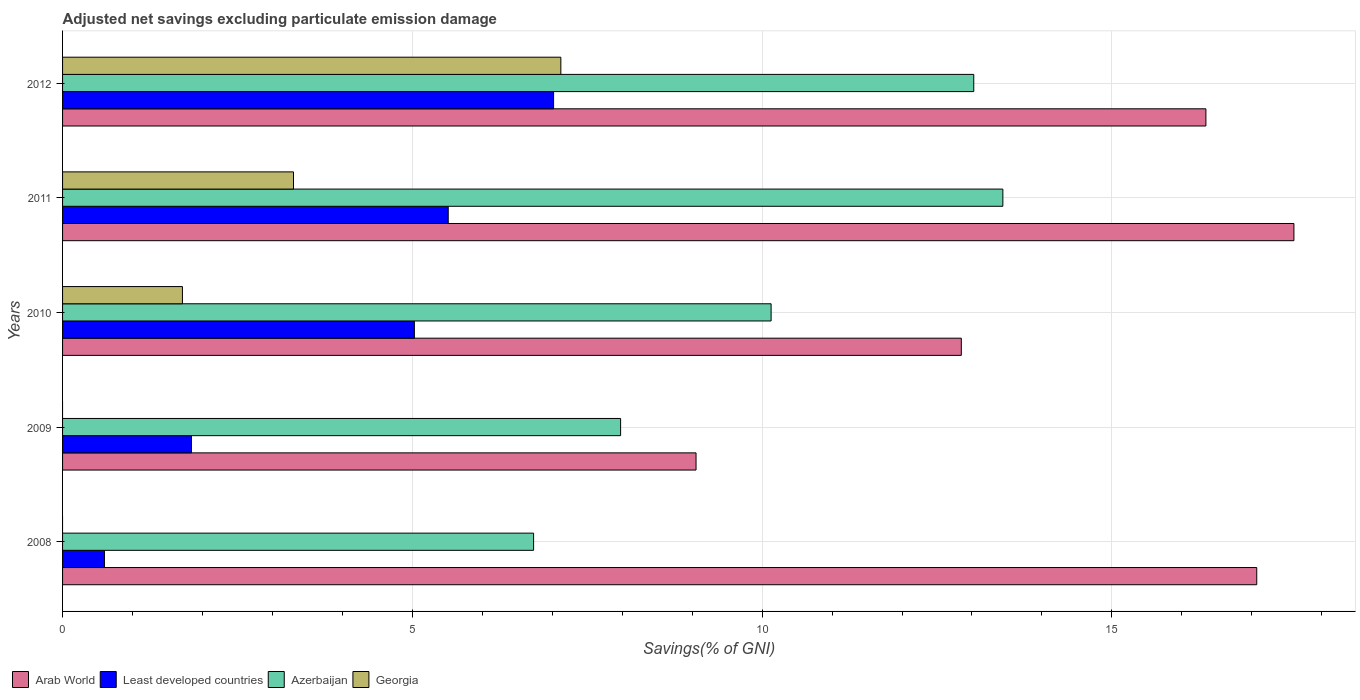How many groups of bars are there?
Provide a succinct answer. 5. How many bars are there on the 5th tick from the top?
Provide a short and direct response. 3. How many bars are there on the 3rd tick from the bottom?
Keep it short and to the point. 4. What is the adjusted net savings in Least developed countries in 2010?
Your answer should be compact. 5.03. Across all years, what is the maximum adjusted net savings in Least developed countries?
Keep it short and to the point. 7.02. Across all years, what is the minimum adjusted net savings in Georgia?
Provide a succinct answer. 0. In which year was the adjusted net savings in Georgia maximum?
Provide a short and direct response. 2012. What is the total adjusted net savings in Azerbaijan in the graph?
Offer a terse response. 51.31. What is the difference between the adjusted net savings in Arab World in 2009 and that in 2012?
Your answer should be compact. -7.29. What is the difference between the adjusted net savings in Georgia in 2010 and the adjusted net savings in Arab World in 2012?
Offer a very short reply. -14.63. What is the average adjusted net savings in Arab World per year?
Give a very brief answer. 14.58. In the year 2011, what is the difference between the adjusted net savings in Georgia and adjusted net savings in Least developed countries?
Provide a succinct answer. -2.21. What is the ratio of the adjusted net savings in Least developed countries in 2008 to that in 2009?
Your response must be concise. 0.32. Is the difference between the adjusted net savings in Georgia in 2010 and 2011 greater than the difference between the adjusted net savings in Least developed countries in 2010 and 2011?
Offer a very short reply. No. What is the difference between the highest and the second highest adjusted net savings in Azerbaijan?
Your answer should be very brief. 0.42. What is the difference between the highest and the lowest adjusted net savings in Arab World?
Your response must be concise. 8.55. Is the sum of the adjusted net savings in Arab World in 2008 and 2012 greater than the maximum adjusted net savings in Azerbaijan across all years?
Keep it short and to the point. Yes. Is it the case that in every year, the sum of the adjusted net savings in Azerbaijan and adjusted net savings in Least developed countries is greater than the sum of adjusted net savings in Arab World and adjusted net savings in Georgia?
Keep it short and to the point. No. What is the difference between two consecutive major ticks on the X-axis?
Provide a short and direct response. 5. Does the graph contain any zero values?
Provide a succinct answer. Yes. Where does the legend appear in the graph?
Offer a terse response. Bottom left. How many legend labels are there?
Ensure brevity in your answer.  4. What is the title of the graph?
Your answer should be very brief. Adjusted net savings excluding particulate emission damage. Does "Isle of Man" appear as one of the legend labels in the graph?
Make the answer very short. No. What is the label or title of the X-axis?
Your answer should be very brief. Savings(% of GNI). What is the label or title of the Y-axis?
Provide a succinct answer. Years. What is the Savings(% of GNI) in Arab World in 2008?
Your answer should be compact. 17.07. What is the Savings(% of GNI) of Least developed countries in 2008?
Keep it short and to the point. 0.6. What is the Savings(% of GNI) in Azerbaijan in 2008?
Offer a very short reply. 6.73. What is the Savings(% of GNI) of Georgia in 2008?
Make the answer very short. 0. What is the Savings(% of GNI) of Arab World in 2009?
Offer a very short reply. 9.06. What is the Savings(% of GNI) of Least developed countries in 2009?
Provide a succinct answer. 1.84. What is the Savings(% of GNI) in Azerbaijan in 2009?
Give a very brief answer. 7.98. What is the Savings(% of GNI) in Georgia in 2009?
Your answer should be very brief. 0. What is the Savings(% of GNI) of Arab World in 2010?
Give a very brief answer. 12.85. What is the Savings(% of GNI) in Least developed countries in 2010?
Your response must be concise. 5.03. What is the Savings(% of GNI) of Azerbaijan in 2010?
Provide a succinct answer. 10.13. What is the Savings(% of GNI) of Georgia in 2010?
Offer a very short reply. 1.71. What is the Savings(% of GNI) of Arab World in 2011?
Keep it short and to the point. 17.6. What is the Savings(% of GNI) in Least developed countries in 2011?
Provide a succinct answer. 5.51. What is the Savings(% of GNI) in Azerbaijan in 2011?
Give a very brief answer. 13.44. What is the Savings(% of GNI) in Georgia in 2011?
Your answer should be very brief. 3.3. What is the Savings(% of GNI) of Arab World in 2012?
Your answer should be very brief. 16.34. What is the Savings(% of GNI) in Least developed countries in 2012?
Provide a succinct answer. 7.02. What is the Savings(% of GNI) in Azerbaijan in 2012?
Your answer should be compact. 13.03. What is the Savings(% of GNI) of Georgia in 2012?
Provide a short and direct response. 7.12. Across all years, what is the maximum Savings(% of GNI) of Arab World?
Offer a very short reply. 17.6. Across all years, what is the maximum Savings(% of GNI) in Least developed countries?
Offer a terse response. 7.02. Across all years, what is the maximum Savings(% of GNI) of Azerbaijan?
Provide a succinct answer. 13.44. Across all years, what is the maximum Savings(% of GNI) in Georgia?
Give a very brief answer. 7.12. Across all years, what is the minimum Savings(% of GNI) in Arab World?
Offer a terse response. 9.06. Across all years, what is the minimum Savings(% of GNI) of Least developed countries?
Your response must be concise. 0.6. Across all years, what is the minimum Savings(% of GNI) of Azerbaijan?
Your answer should be compact. 6.73. What is the total Savings(% of GNI) of Arab World in the graph?
Provide a succinct answer. 72.92. What is the total Savings(% of GNI) of Least developed countries in the graph?
Give a very brief answer. 20. What is the total Savings(% of GNI) of Azerbaijan in the graph?
Provide a succinct answer. 51.31. What is the total Savings(% of GNI) in Georgia in the graph?
Provide a succinct answer. 12.14. What is the difference between the Savings(% of GNI) in Arab World in 2008 and that in 2009?
Offer a terse response. 8.02. What is the difference between the Savings(% of GNI) in Least developed countries in 2008 and that in 2009?
Your answer should be very brief. -1.24. What is the difference between the Savings(% of GNI) in Azerbaijan in 2008 and that in 2009?
Your answer should be compact. -1.24. What is the difference between the Savings(% of GNI) in Arab World in 2008 and that in 2010?
Your response must be concise. 4.22. What is the difference between the Savings(% of GNI) of Least developed countries in 2008 and that in 2010?
Offer a very short reply. -4.43. What is the difference between the Savings(% of GNI) in Azerbaijan in 2008 and that in 2010?
Keep it short and to the point. -3.4. What is the difference between the Savings(% of GNI) of Arab World in 2008 and that in 2011?
Ensure brevity in your answer.  -0.53. What is the difference between the Savings(% of GNI) in Least developed countries in 2008 and that in 2011?
Offer a very short reply. -4.91. What is the difference between the Savings(% of GNI) of Azerbaijan in 2008 and that in 2011?
Make the answer very short. -6.71. What is the difference between the Savings(% of GNI) in Arab World in 2008 and that in 2012?
Make the answer very short. 0.73. What is the difference between the Savings(% of GNI) of Least developed countries in 2008 and that in 2012?
Your answer should be very brief. -6.42. What is the difference between the Savings(% of GNI) in Azerbaijan in 2008 and that in 2012?
Offer a very short reply. -6.29. What is the difference between the Savings(% of GNI) in Arab World in 2009 and that in 2010?
Your answer should be very brief. -3.79. What is the difference between the Savings(% of GNI) in Least developed countries in 2009 and that in 2010?
Your response must be concise. -3.19. What is the difference between the Savings(% of GNI) in Azerbaijan in 2009 and that in 2010?
Ensure brevity in your answer.  -2.15. What is the difference between the Savings(% of GNI) of Arab World in 2009 and that in 2011?
Your answer should be compact. -8.55. What is the difference between the Savings(% of GNI) of Least developed countries in 2009 and that in 2011?
Your response must be concise. -3.67. What is the difference between the Savings(% of GNI) of Azerbaijan in 2009 and that in 2011?
Ensure brevity in your answer.  -5.46. What is the difference between the Savings(% of GNI) in Arab World in 2009 and that in 2012?
Offer a terse response. -7.29. What is the difference between the Savings(% of GNI) of Least developed countries in 2009 and that in 2012?
Your response must be concise. -5.18. What is the difference between the Savings(% of GNI) of Azerbaijan in 2009 and that in 2012?
Make the answer very short. -5.05. What is the difference between the Savings(% of GNI) of Arab World in 2010 and that in 2011?
Provide a succinct answer. -4.75. What is the difference between the Savings(% of GNI) in Least developed countries in 2010 and that in 2011?
Your answer should be very brief. -0.48. What is the difference between the Savings(% of GNI) in Azerbaijan in 2010 and that in 2011?
Offer a terse response. -3.31. What is the difference between the Savings(% of GNI) of Georgia in 2010 and that in 2011?
Make the answer very short. -1.59. What is the difference between the Savings(% of GNI) in Arab World in 2010 and that in 2012?
Provide a succinct answer. -3.5. What is the difference between the Savings(% of GNI) of Least developed countries in 2010 and that in 2012?
Your response must be concise. -1.99. What is the difference between the Savings(% of GNI) of Azerbaijan in 2010 and that in 2012?
Provide a succinct answer. -2.9. What is the difference between the Savings(% of GNI) of Georgia in 2010 and that in 2012?
Your answer should be compact. -5.41. What is the difference between the Savings(% of GNI) in Arab World in 2011 and that in 2012?
Your answer should be compact. 1.26. What is the difference between the Savings(% of GNI) in Least developed countries in 2011 and that in 2012?
Give a very brief answer. -1.51. What is the difference between the Savings(% of GNI) in Azerbaijan in 2011 and that in 2012?
Ensure brevity in your answer.  0.42. What is the difference between the Savings(% of GNI) in Georgia in 2011 and that in 2012?
Keep it short and to the point. -3.82. What is the difference between the Savings(% of GNI) in Arab World in 2008 and the Savings(% of GNI) in Least developed countries in 2009?
Provide a succinct answer. 15.23. What is the difference between the Savings(% of GNI) of Arab World in 2008 and the Savings(% of GNI) of Azerbaijan in 2009?
Provide a succinct answer. 9.09. What is the difference between the Savings(% of GNI) of Least developed countries in 2008 and the Savings(% of GNI) of Azerbaijan in 2009?
Give a very brief answer. -7.38. What is the difference between the Savings(% of GNI) of Arab World in 2008 and the Savings(% of GNI) of Least developed countries in 2010?
Your response must be concise. 12.04. What is the difference between the Savings(% of GNI) in Arab World in 2008 and the Savings(% of GNI) in Azerbaijan in 2010?
Your response must be concise. 6.94. What is the difference between the Savings(% of GNI) in Arab World in 2008 and the Savings(% of GNI) in Georgia in 2010?
Give a very brief answer. 15.36. What is the difference between the Savings(% of GNI) in Least developed countries in 2008 and the Savings(% of GNI) in Azerbaijan in 2010?
Your response must be concise. -9.53. What is the difference between the Savings(% of GNI) of Least developed countries in 2008 and the Savings(% of GNI) of Georgia in 2010?
Keep it short and to the point. -1.11. What is the difference between the Savings(% of GNI) of Azerbaijan in 2008 and the Savings(% of GNI) of Georgia in 2010?
Keep it short and to the point. 5.02. What is the difference between the Savings(% of GNI) in Arab World in 2008 and the Savings(% of GNI) in Least developed countries in 2011?
Offer a very short reply. 11.56. What is the difference between the Savings(% of GNI) in Arab World in 2008 and the Savings(% of GNI) in Azerbaijan in 2011?
Make the answer very short. 3.63. What is the difference between the Savings(% of GNI) of Arab World in 2008 and the Savings(% of GNI) of Georgia in 2011?
Make the answer very short. 13.77. What is the difference between the Savings(% of GNI) of Least developed countries in 2008 and the Savings(% of GNI) of Azerbaijan in 2011?
Give a very brief answer. -12.84. What is the difference between the Savings(% of GNI) in Least developed countries in 2008 and the Savings(% of GNI) in Georgia in 2011?
Your answer should be compact. -2.7. What is the difference between the Savings(% of GNI) of Azerbaijan in 2008 and the Savings(% of GNI) of Georgia in 2011?
Give a very brief answer. 3.43. What is the difference between the Savings(% of GNI) in Arab World in 2008 and the Savings(% of GNI) in Least developed countries in 2012?
Provide a short and direct response. 10.05. What is the difference between the Savings(% of GNI) of Arab World in 2008 and the Savings(% of GNI) of Azerbaijan in 2012?
Keep it short and to the point. 4.05. What is the difference between the Savings(% of GNI) of Arab World in 2008 and the Savings(% of GNI) of Georgia in 2012?
Your answer should be very brief. 9.95. What is the difference between the Savings(% of GNI) of Least developed countries in 2008 and the Savings(% of GNI) of Azerbaijan in 2012?
Make the answer very short. -12.43. What is the difference between the Savings(% of GNI) of Least developed countries in 2008 and the Savings(% of GNI) of Georgia in 2012?
Keep it short and to the point. -6.52. What is the difference between the Savings(% of GNI) of Azerbaijan in 2008 and the Savings(% of GNI) of Georgia in 2012?
Keep it short and to the point. -0.39. What is the difference between the Savings(% of GNI) in Arab World in 2009 and the Savings(% of GNI) in Least developed countries in 2010?
Your response must be concise. 4.03. What is the difference between the Savings(% of GNI) in Arab World in 2009 and the Savings(% of GNI) in Azerbaijan in 2010?
Ensure brevity in your answer.  -1.07. What is the difference between the Savings(% of GNI) of Arab World in 2009 and the Savings(% of GNI) of Georgia in 2010?
Give a very brief answer. 7.34. What is the difference between the Savings(% of GNI) of Least developed countries in 2009 and the Savings(% of GNI) of Azerbaijan in 2010?
Provide a short and direct response. -8.29. What is the difference between the Savings(% of GNI) of Least developed countries in 2009 and the Savings(% of GNI) of Georgia in 2010?
Keep it short and to the point. 0.13. What is the difference between the Savings(% of GNI) in Azerbaijan in 2009 and the Savings(% of GNI) in Georgia in 2010?
Keep it short and to the point. 6.26. What is the difference between the Savings(% of GNI) of Arab World in 2009 and the Savings(% of GNI) of Least developed countries in 2011?
Make the answer very short. 3.54. What is the difference between the Savings(% of GNI) of Arab World in 2009 and the Savings(% of GNI) of Azerbaijan in 2011?
Keep it short and to the point. -4.39. What is the difference between the Savings(% of GNI) in Arab World in 2009 and the Savings(% of GNI) in Georgia in 2011?
Your answer should be very brief. 5.75. What is the difference between the Savings(% of GNI) of Least developed countries in 2009 and the Savings(% of GNI) of Azerbaijan in 2011?
Your answer should be very brief. -11.6. What is the difference between the Savings(% of GNI) in Least developed countries in 2009 and the Savings(% of GNI) in Georgia in 2011?
Keep it short and to the point. -1.46. What is the difference between the Savings(% of GNI) of Azerbaijan in 2009 and the Savings(% of GNI) of Georgia in 2011?
Offer a very short reply. 4.68. What is the difference between the Savings(% of GNI) in Arab World in 2009 and the Savings(% of GNI) in Least developed countries in 2012?
Your answer should be compact. 2.04. What is the difference between the Savings(% of GNI) of Arab World in 2009 and the Savings(% of GNI) of Azerbaijan in 2012?
Make the answer very short. -3.97. What is the difference between the Savings(% of GNI) in Arab World in 2009 and the Savings(% of GNI) in Georgia in 2012?
Your response must be concise. 1.93. What is the difference between the Savings(% of GNI) in Least developed countries in 2009 and the Savings(% of GNI) in Azerbaijan in 2012?
Offer a very short reply. -11.18. What is the difference between the Savings(% of GNI) in Least developed countries in 2009 and the Savings(% of GNI) in Georgia in 2012?
Provide a short and direct response. -5.28. What is the difference between the Savings(% of GNI) in Azerbaijan in 2009 and the Savings(% of GNI) in Georgia in 2012?
Keep it short and to the point. 0.85. What is the difference between the Savings(% of GNI) in Arab World in 2010 and the Savings(% of GNI) in Least developed countries in 2011?
Offer a terse response. 7.33. What is the difference between the Savings(% of GNI) of Arab World in 2010 and the Savings(% of GNI) of Azerbaijan in 2011?
Provide a succinct answer. -0.59. What is the difference between the Savings(% of GNI) of Arab World in 2010 and the Savings(% of GNI) of Georgia in 2011?
Give a very brief answer. 9.55. What is the difference between the Savings(% of GNI) of Least developed countries in 2010 and the Savings(% of GNI) of Azerbaijan in 2011?
Your answer should be compact. -8.41. What is the difference between the Savings(% of GNI) of Least developed countries in 2010 and the Savings(% of GNI) of Georgia in 2011?
Your answer should be very brief. 1.73. What is the difference between the Savings(% of GNI) in Azerbaijan in 2010 and the Savings(% of GNI) in Georgia in 2011?
Keep it short and to the point. 6.83. What is the difference between the Savings(% of GNI) in Arab World in 2010 and the Savings(% of GNI) in Least developed countries in 2012?
Provide a short and direct response. 5.83. What is the difference between the Savings(% of GNI) in Arab World in 2010 and the Savings(% of GNI) in Azerbaijan in 2012?
Ensure brevity in your answer.  -0.18. What is the difference between the Savings(% of GNI) of Arab World in 2010 and the Savings(% of GNI) of Georgia in 2012?
Offer a terse response. 5.72. What is the difference between the Savings(% of GNI) in Least developed countries in 2010 and the Savings(% of GNI) in Azerbaijan in 2012?
Provide a succinct answer. -8. What is the difference between the Savings(% of GNI) in Least developed countries in 2010 and the Savings(% of GNI) in Georgia in 2012?
Offer a terse response. -2.09. What is the difference between the Savings(% of GNI) of Azerbaijan in 2010 and the Savings(% of GNI) of Georgia in 2012?
Provide a short and direct response. 3.01. What is the difference between the Savings(% of GNI) in Arab World in 2011 and the Savings(% of GNI) in Least developed countries in 2012?
Ensure brevity in your answer.  10.58. What is the difference between the Savings(% of GNI) of Arab World in 2011 and the Savings(% of GNI) of Azerbaijan in 2012?
Offer a terse response. 4.58. What is the difference between the Savings(% of GNI) of Arab World in 2011 and the Savings(% of GNI) of Georgia in 2012?
Ensure brevity in your answer.  10.48. What is the difference between the Savings(% of GNI) in Least developed countries in 2011 and the Savings(% of GNI) in Azerbaijan in 2012?
Make the answer very short. -7.51. What is the difference between the Savings(% of GNI) of Least developed countries in 2011 and the Savings(% of GNI) of Georgia in 2012?
Ensure brevity in your answer.  -1.61. What is the difference between the Savings(% of GNI) in Azerbaijan in 2011 and the Savings(% of GNI) in Georgia in 2012?
Your response must be concise. 6.32. What is the average Savings(% of GNI) of Arab World per year?
Your response must be concise. 14.58. What is the average Savings(% of GNI) in Least developed countries per year?
Your answer should be compact. 4. What is the average Savings(% of GNI) of Azerbaijan per year?
Give a very brief answer. 10.26. What is the average Savings(% of GNI) in Georgia per year?
Offer a very short reply. 2.43. In the year 2008, what is the difference between the Savings(% of GNI) in Arab World and Savings(% of GNI) in Least developed countries?
Your response must be concise. 16.47. In the year 2008, what is the difference between the Savings(% of GNI) in Arab World and Savings(% of GNI) in Azerbaijan?
Your answer should be compact. 10.34. In the year 2008, what is the difference between the Savings(% of GNI) in Least developed countries and Savings(% of GNI) in Azerbaijan?
Give a very brief answer. -6.13. In the year 2009, what is the difference between the Savings(% of GNI) in Arab World and Savings(% of GNI) in Least developed countries?
Your response must be concise. 7.21. In the year 2009, what is the difference between the Savings(% of GNI) of Arab World and Savings(% of GNI) of Azerbaijan?
Offer a terse response. 1.08. In the year 2009, what is the difference between the Savings(% of GNI) of Least developed countries and Savings(% of GNI) of Azerbaijan?
Your answer should be very brief. -6.13. In the year 2010, what is the difference between the Savings(% of GNI) of Arab World and Savings(% of GNI) of Least developed countries?
Keep it short and to the point. 7.82. In the year 2010, what is the difference between the Savings(% of GNI) in Arab World and Savings(% of GNI) in Azerbaijan?
Offer a very short reply. 2.72. In the year 2010, what is the difference between the Savings(% of GNI) of Arab World and Savings(% of GNI) of Georgia?
Offer a terse response. 11.13. In the year 2010, what is the difference between the Savings(% of GNI) in Least developed countries and Savings(% of GNI) in Azerbaijan?
Your answer should be very brief. -5.1. In the year 2010, what is the difference between the Savings(% of GNI) of Least developed countries and Savings(% of GNI) of Georgia?
Ensure brevity in your answer.  3.32. In the year 2010, what is the difference between the Savings(% of GNI) of Azerbaijan and Savings(% of GNI) of Georgia?
Your answer should be compact. 8.41. In the year 2011, what is the difference between the Savings(% of GNI) in Arab World and Savings(% of GNI) in Least developed countries?
Your response must be concise. 12.09. In the year 2011, what is the difference between the Savings(% of GNI) in Arab World and Savings(% of GNI) in Azerbaijan?
Keep it short and to the point. 4.16. In the year 2011, what is the difference between the Savings(% of GNI) of Arab World and Savings(% of GNI) of Georgia?
Give a very brief answer. 14.3. In the year 2011, what is the difference between the Savings(% of GNI) in Least developed countries and Savings(% of GNI) in Azerbaijan?
Keep it short and to the point. -7.93. In the year 2011, what is the difference between the Savings(% of GNI) of Least developed countries and Savings(% of GNI) of Georgia?
Give a very brief answer. 2.21. In the year 2011, what is the difference between the Savings(% of GNI) in Azerbaijan and Savings(% of GNI) in Georgia?
Your response must be concise. 10.14. In the year 2012, what is the difference between the Savings(% of GNI) in Arab World and Savings(% of GNI) in Least developed countries?
Offer a very short reply. 9.32. In the year 2012, what is the difference between the Savings(% of GNI) of Arab World and Savings(% of GNI) of Azerbaijan?
Give a very brief answer. 3.32. In the year 2012, what is the difference between the Savings(% of GNI) in Arab World and Savings(% of GNI) in Georgia?
Give a very brief answer. 9.22. In the year 2012, what is the difference between the Savings(% of GNI) of Least developed countries and Savings(% of GNI) of Azerbaijan?
Provide a succinct answer. -6.01. In the year 2012, what is the difference between the Savings(% of GNI) of Least developed countries and Savings(% of GNI) of Georgia?
Provide a short and direct response. -0.1. In the year 2012, what is the difference between the Savings(% of GNI) of Azerbaijan and Savings(% of GNI) of Georgia?
Your response must be concise. 5.9. What is the ratio of the Savings(% of GNI) in Arab World in 2008 to that in 2009?
Offer a terse response. 1.89. What is the ratio of the Savings(% of GNI) in Least developed countries in 2008 to that in 2009?
Provide a short and direct response. 0.33. What is the ratio of the Savings(% of GNI) of Azerbaijan in 2008 to that in 2009?
Provide a succinct answer. 0.84. What is the ratio of the Savings(% of GNI) of Arab World in 2008 to that in 2010?
Give a very brief answer. 1.33. What is the ratio of the Savings(% of GNI) of Least developed countries in 2008 to that in 2010?
Ensure brevity in your answer.  0.12. What is the ratio of the Savings(% of GNI) of Azerbaijan in 2008 to that in 2010?
Your answer should be very brief. 0.66. What is the ratio of the Savings(% of GNI) in Arab World in 2008 to that in 2011?
Your response must be concise. 0.97. What is the ratio of the Savings(% of GNI) in Least developed countries in 2008 to that in 2011?
Provide a succinct answer. 0.11. What is the ratio of the Savings(% of GNI) in Azerbaijan in 2008 to that in 2011?
Your answer should be compact. 0.5. What is the ratio of the Savings(% of GNI) in Arab World in 2008 to that in 2012?
Your answer should be very brief. 1.04. What is the ratio of the Savings(% of GNI) of Least developed countries in 2008 to that in 2012?
Your response must be concise. 0.09. What is the ratio of the Savings(% of GNI) of Azerbaijan in 2008 to that in 2012?
Your answer should be compact. 0.52. What is the ratio of the Savings(% of GNI) in Arab World in 2009 to that in 2010?
Provide a short and direct response. 0.7. What is the ratio of the Savings(% of GNI) of Least developed countries in 2009 to that in 2010?
Make the answer very short. 0.37. What is the ratio of the Savings(% of GNI) in Azerbaijan in 2009 to that in 2010?
Give a very brief answer. 0.79. What is the ratio of the Savings(% of GNI) of Arab World in 2009 to that in 2011?
Ensure brevity in your answer.  0.51. What is the ratio of the Savings(% of GNI) in Least developed countries in 2009 to that in 2011?
Give a very brief answer. 0.33. What is the ratio of the Savings(% of GNI) of Azerbaijan in 2009 to that in 2011?
Your answer should be very brief. 0.59. What is the ratio of the Savings(% of GNI) in Arab World in 2009 to that in 2012?
Ensure brevity in your answer.  0.55. What is the ratio of the Savings(% of GNI) of Least developed countries in 2009 to that in 2012?
Your answer should be compact. 0.26. What is the ratio of the Savings(% of GNI) of Azerbaijan in 2009 to that in 2012?
Make the answer very short. 0.61. What is the ratio of the Savings(% of GNI) in Arab World in 2010 to that in 2011?
Ensure brevity in your answer.  0.73. What is the ratio of the Savings(% of GNI) of Least developed countries in 2010 to that in 2011?
Your answer should be very brief. 0.91. What is the ratio of the Savings(% of GNI) of Azerbaijan in 2010 to that in 2011?
Make the answer very short. 0.75. What is the ratio of the Savings(% of GNI) of Georgia in 2010 to that in 2011?
Keep it short and to the point. 0.52. What is the ratio of the Savings(% of GNI) of Arab World in 2010 to that in 2012?
Offer a terse response. 0.79. What is the ratio of the Savings(% of GNI) in Least developed countries in 2010 to that in 2012?
Your answer should be compact. 0.72. What is the ratio of the Savings(% of GNI) of Azerbaijan in 2010 to that in 2012?
Provide a short and direct response. 0.78. What is the ratio of the Savings(% of GNI) in Georgia in 2010 to that in 2012?
Provide a succinct answer. 0.24. What is the ratio of the Savings(% of GNI) in Arab World in 2011 to that in 2012?
Offer a very short reply. 1.08. What is the ratio of the Savings(% of GNI) in Least developed countries in 2011 to that in 2012?
Offer a very short reply. 0.79. What is the ratio of the Savings(% of GNI) in Azerbaijan in 2011 to that in 2012?
Offer a very short reply. 1.03. What is the ratio of the Savings(% of GNI) of Georgia in 2011 to that in 2012?
Your answer should be compact. 0.46. What is the difference between the highest and the second highest Savings(% of GNI) of Arab World?
Make the answer very short. 0.53. What is the difference between the highest and the second highest Savings(% of GNI) of Least developed countries?
Offer a very short reply. 1.51. What is the difference between the highest and the second highest Savings(% of GNI) of Azerbaijan?
Give a very brief answer. 0.42. What is the difference between the highest and the second highest Savings(% of GNI) of Georgia?
Offer a terse response. 3.82. What is the difference between the highest and the lowest Savings(% of GNI) of Arab World?
Offer a very short reply. 8.55. What is the difference between the highest and the lowest Savings(% of GNI) of Least developed countries?
Provide a short and direct response. 6.42. What is the difference between the highest and the lowest Savings(% of GNI) of Azerbaijan?
Give a very brief answer. 6.71. What is the difference between the highest and the lowest Savings(% of GNI) of Georgia?
Provide a succinct answer. 7.12. 